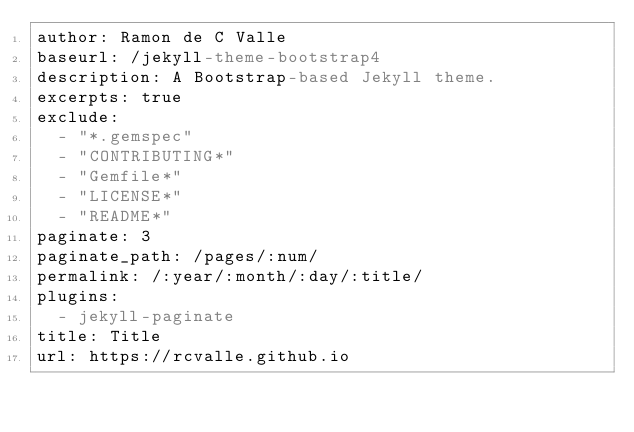Convert code to text. <code><loc_0><loc_0><loc_500><loc_500><_YAML_>author: Ramon de C Valle
baseurl: /jekyll-theme-bootstrap4
description: A Bootstrap-based Jekyll theme.
excerpts: true
exclude:
  - "*.gemspec"
  - "CONTRIBUTING*"
  - "Gemfile*"
  - "LICENSE*"
  - "README*"
paginate: 3
paginate_path: /pages/:num/
permalink: /:year/:month/:day/:title/
plugins:
  - jekyll-paginate
title: Title
url: https://rcvalle.github.io
</code> 